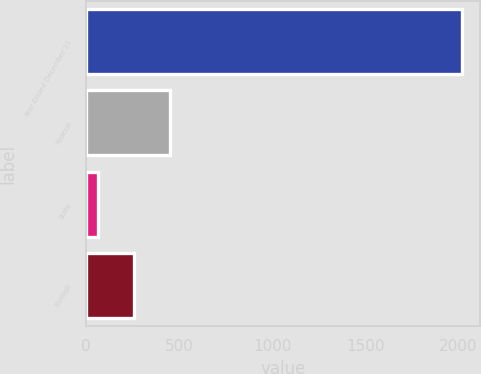Convert chart to OTSL. <chart><loc_0><loc_0><loc_500><loc_500><bar_chart><fcel>Year Ended December 31<fcel>Federal<fcel>State<fcel>Foreign<nl><fcel>2017<fcel>454.44<fcel>63.8<fcel>259.12<nl></chart> 